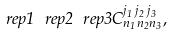Convert formula to latex. <formula><loc_0><loc_0><loc_500><loc_500>\ r e p { 1 } \ r e p { 2 } \ r e p { 3 } C ^ { j _ { 1 } \, j _ { 2 } \, j _ { 3 } } _ { n _ { 1 } n _ { 2 } n _ { 3 } } ,</formula> 